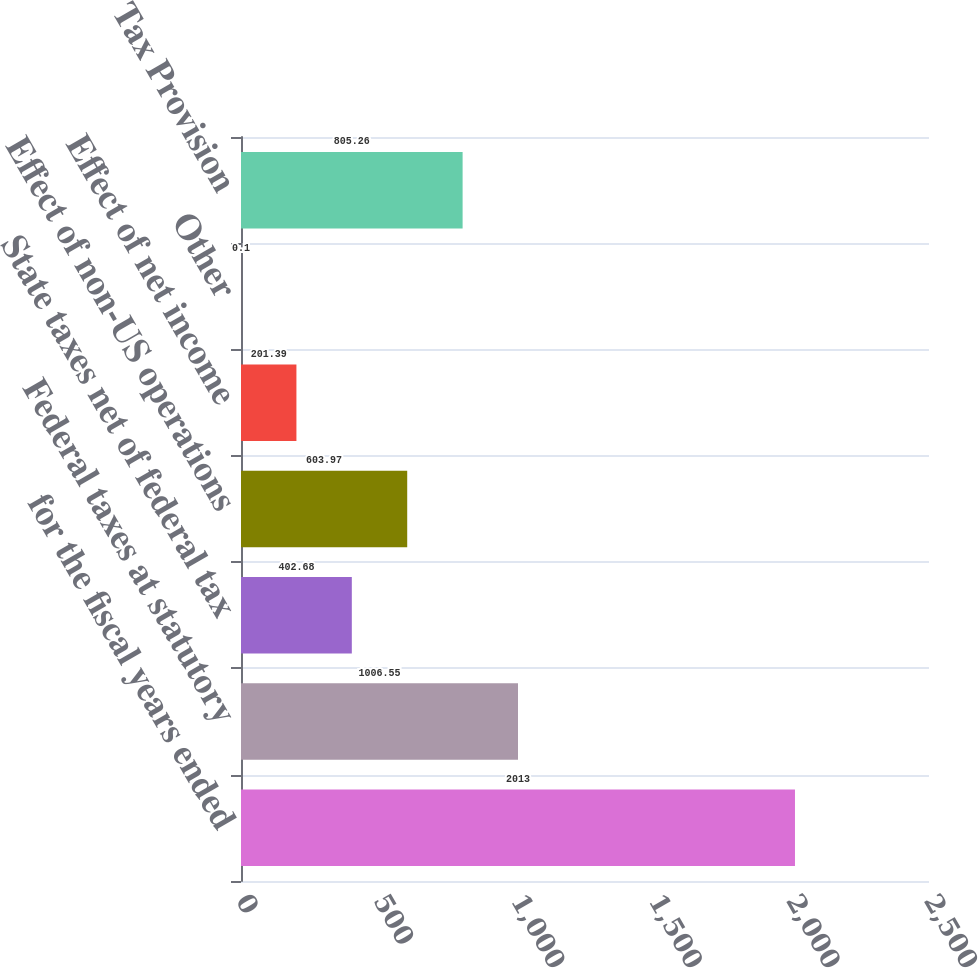<chart> <loc_0><loc_0><loc_500><loc_500><bar_chart><fcel>for the fiscal years ended<fcel>Federal taxes at statutory<fcel>State taxes net of federal tax<fcel>Effect of non-US operations<fcel>Effect of net income<fcel>Other<fcel>Tax Provision<nl><fcel>2013<fcel>1006.55<fcel>402.68<fcel>603.97<fcel>201.39<fcel>0.1<fcel>805.26<nl></chart> 